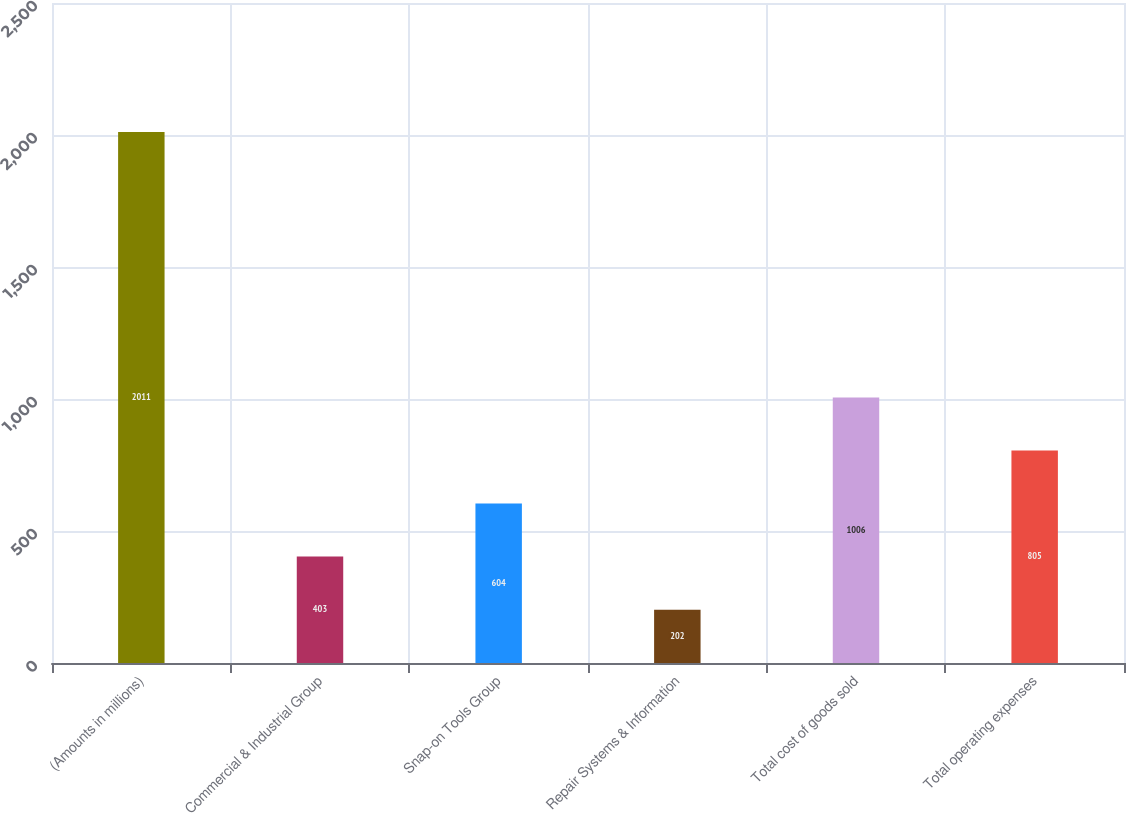<chart> <loc_0><loc_0><loc_500><loc_500><bar_chart><fcel>(Amounts in millions)<fcel>Commercial & Industrial Group<fcel>Snap-on Tools Group<fcel>Repair Systems & Information<fcel>Total cost of goods sold<fcel>Total operating expenses<nl><fcel>2011<fcel>403<fcel>604<fcel>202<fcel>1006<fcel>805<nl></chart> 